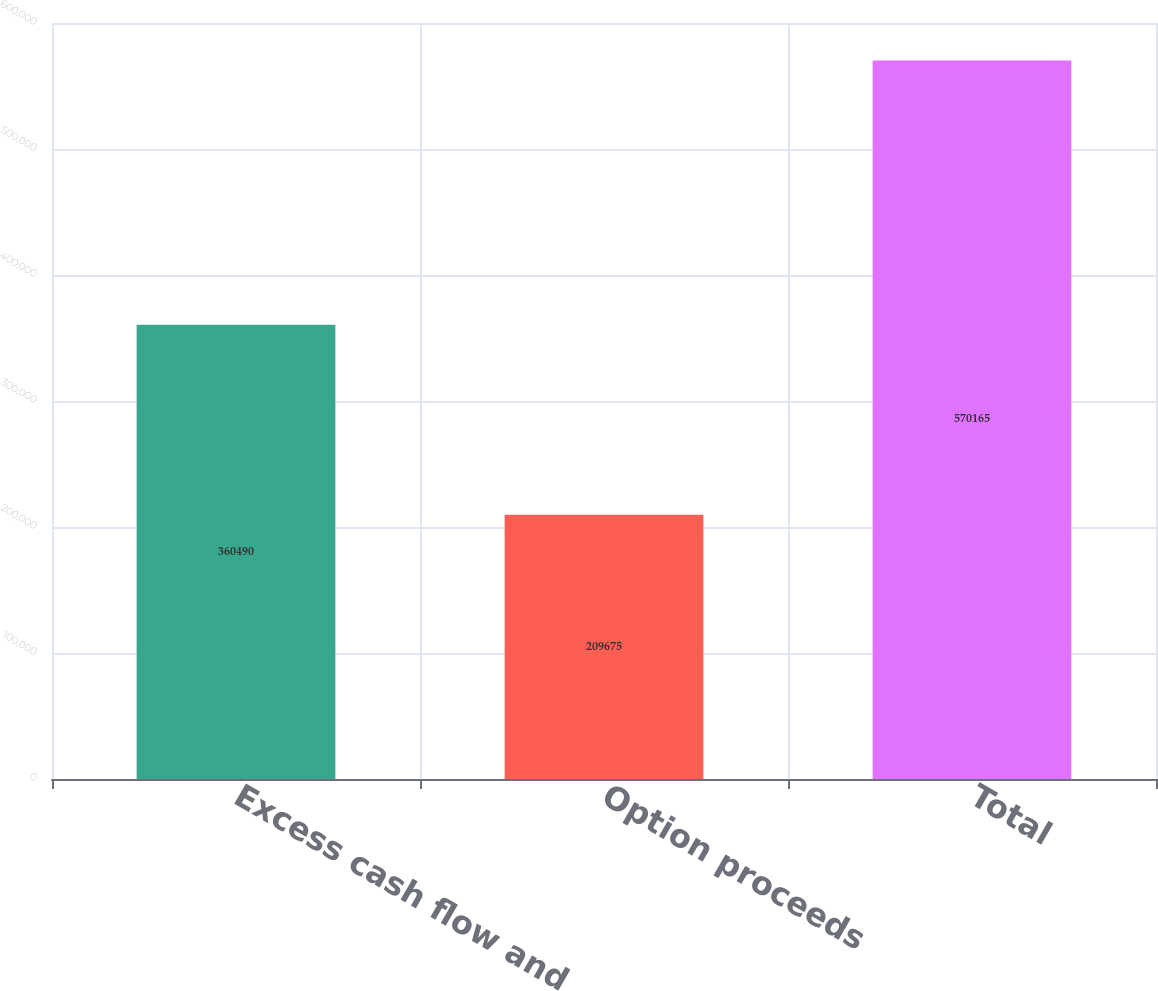Convert chart. <chart><loc_0><loc_0><loc_500><loc_500><bar_chart><fcel>Excess cash flow and<fcel>Option proceeds<fcel>Total<nl><fcel>360490<fcel>209675<fcel>570165<nl></chart> 